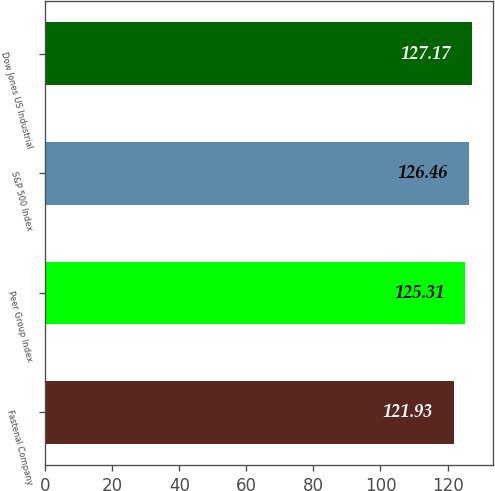Convert chart. <chart><loc_0><loc_0><loc_500><loc_500><bar_chart><fcel>Fastenal Company<fcel>Peer Group Index<fcel>S&P 500 Index<fcel>Dow Jones US Industrial<nl><fcel>121.93<fcel>125.31<fcel>126.46<fcel>127.17<nl></chart> 